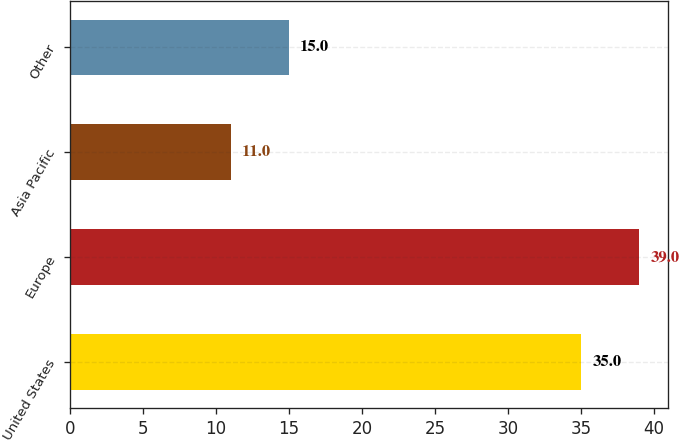<chart> <loc_0><loc_0><loc_500><loc_500><bar_chart><fcel>United States<fcel>Europe<fcel>Asia Pacific<fcel>Other<nl><fcel>35<fcel>39<fcel>11<fcel>15<nl></chart> 